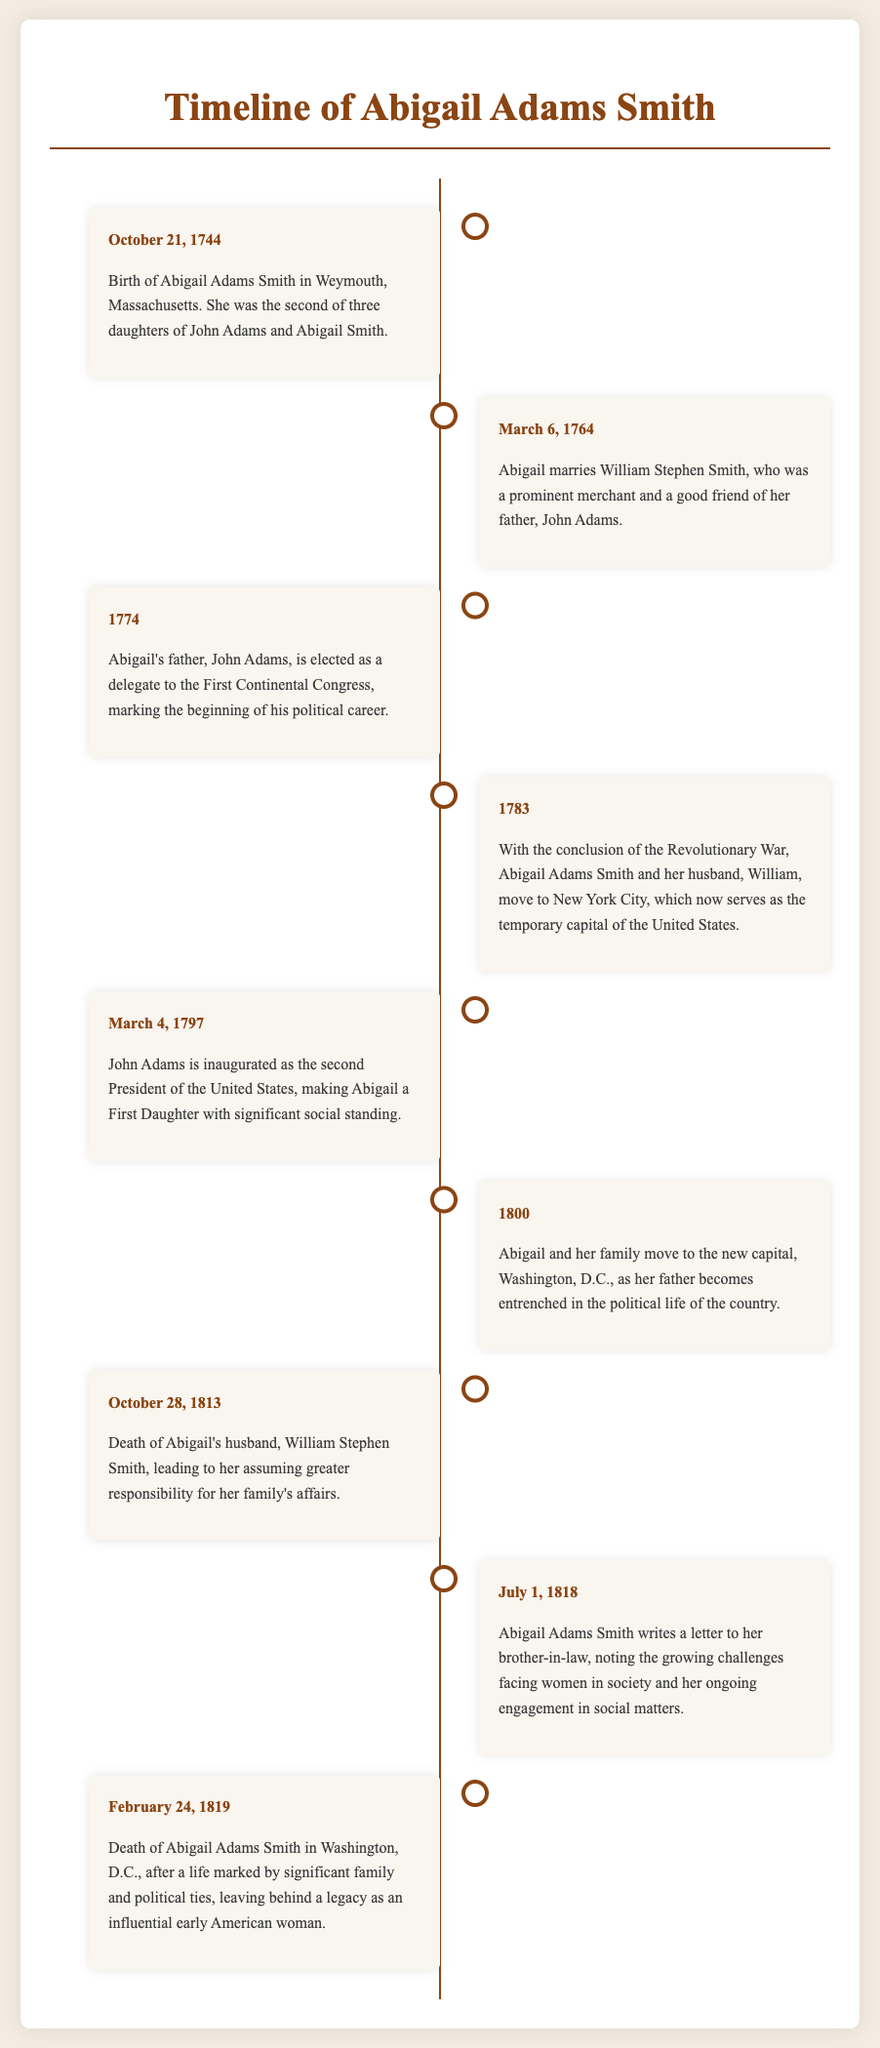What is the birth date of Abigail Adams Smith? The document states her birth date as October 21, 1744.
Answer: October 21, 1744 Who did Abigail marry? The timeline notes that Abigail married William Stephen Smith.
Answer: William Stephen Smith When did John Adams become President? According to the timeline, John Adams was inaugurated on March 4, 1797.
Answer: March 4, 1797 What major life event happened for Abigail in 1813? The document indicates that Abigail's husband, William Stephen Smith, died on October 28, 1813.
Answer: Death of William Stephen Smith What city did Abigail move to in 1783? The timeline mentions that Abigail moved to New York City in 1783.
Answer: New York City How many daughters did John Adams and Abigail Smith have? The document specifies that Abigail was the second of three daughters.
Answer: Three daughters What significant change occurred for the family in 1800? The document describes that Abigail's family moved to Washington, D.C. in 1800.
Answer: Washington, D.C What did Abigail express in her letter on July 1, 1818? The timeline notes that Abigail wrote about the growing challenges facing women in society.
Answer: Challenges facing women When did Abigail Adams Smith pass away? The document records her death on February 24, 1819.
Answer: February 24, 1819 